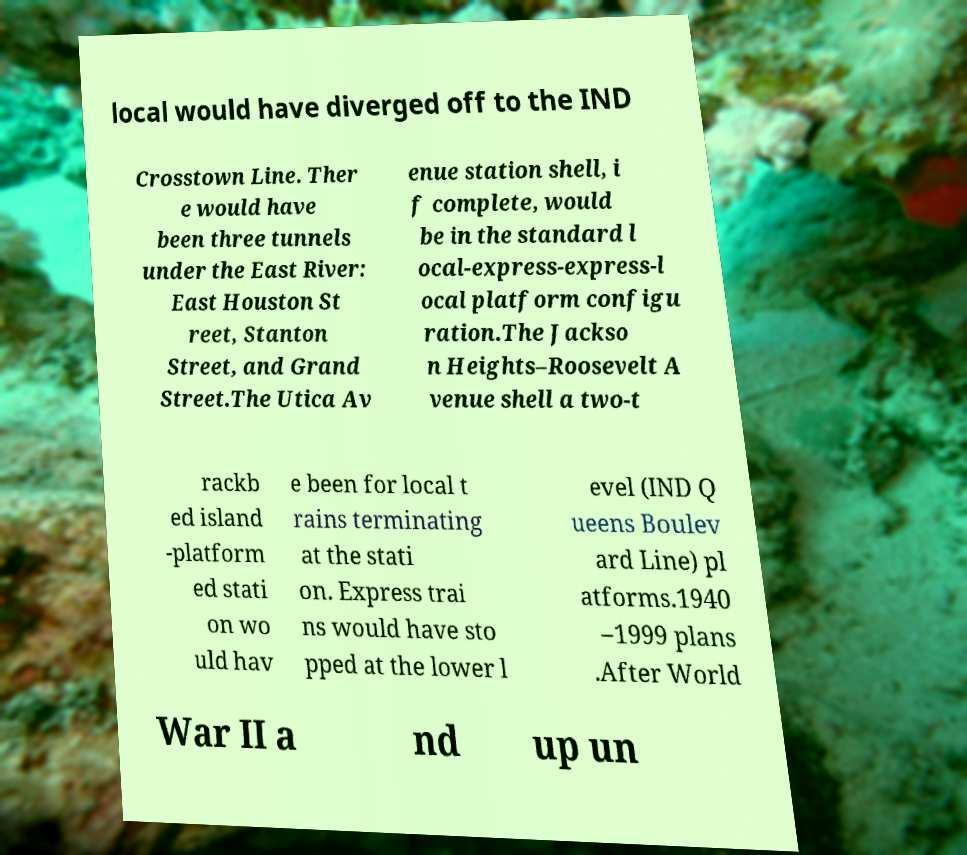For documentation purposes, I need the text within this image transcribed. Could you provide that? local would have diverged off to the IND Crosstown Line. Ther e would have been three tunnels under the East River: East Houston St reet, Stanton Street, and Grand Street.The Utica Av enue station shell, i f complete, would be in the standard l ocal-express-express-l ocal platform configu ration.The Jackso n Heights–Roosevelt A venue shell a two-t rackb ed island -platform ed stati on wo uld hav e been for local t rains terminating at the stati on. Express trai ns would have sto pped at the lower l evel (IND Q ueens Boulev ard Line) pl atforms.1940 –1999 plans .After World War II a nd up un 